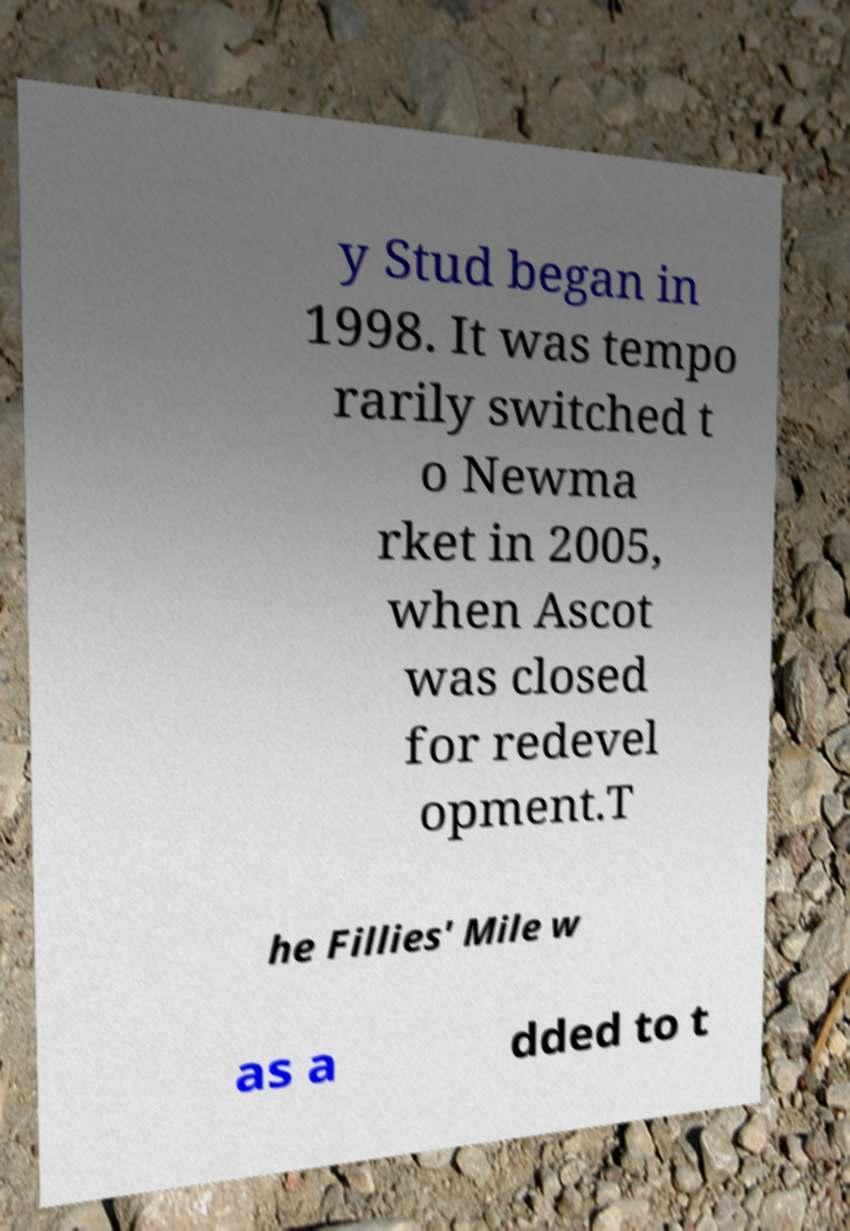Please read and relay the text visible in this image. What does it say? y Stud began in 1998. It was tempo rarily switched t o Newma rket in 2005, when Ascot was closed for redevel opment.T he Fillies' Mile w as a dded to t 